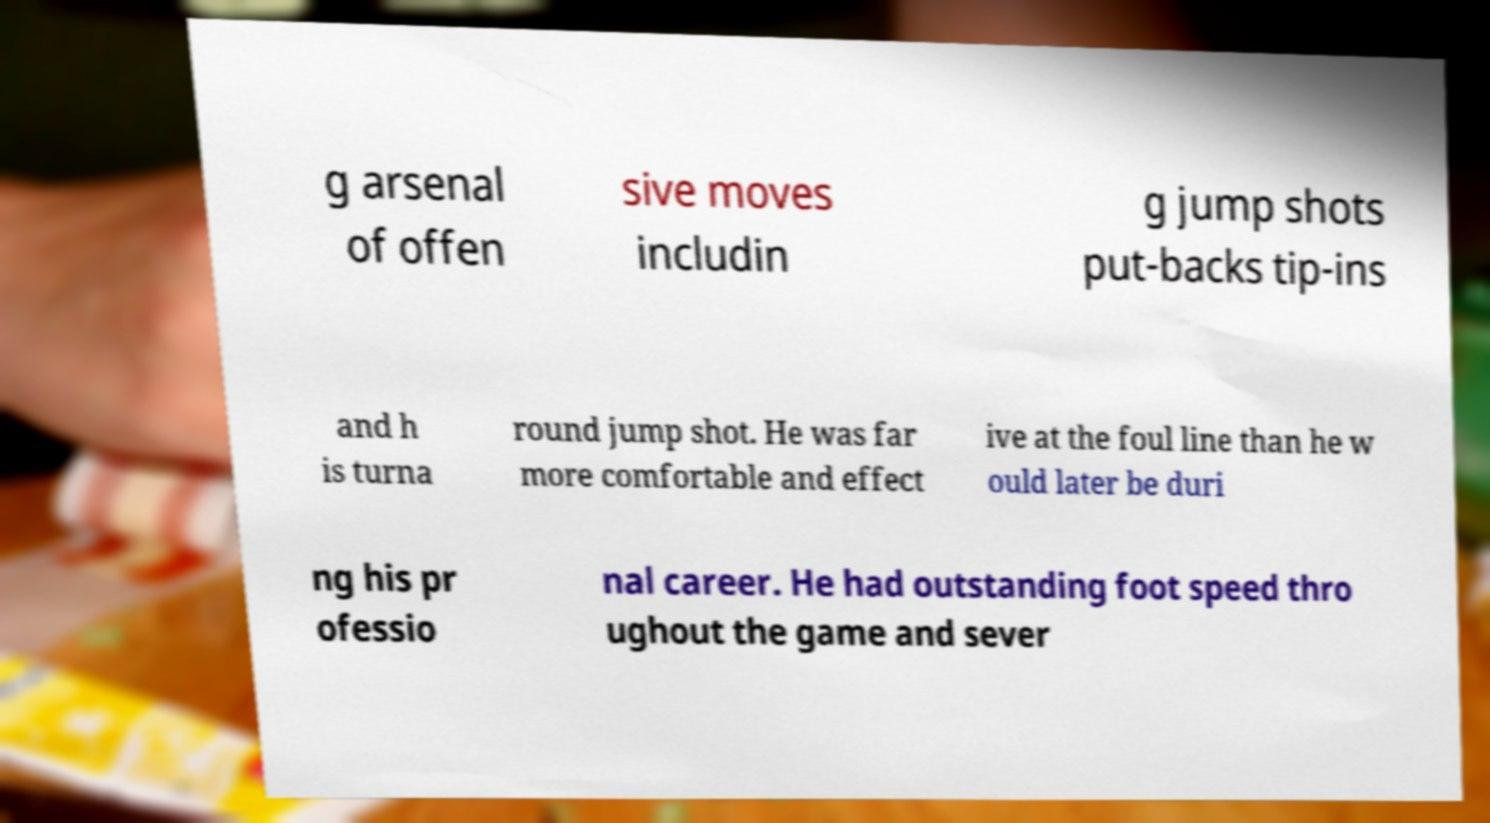Can you accurately transcribe the text from the provided image for me? g arsenal of offen sive moves includin g jump shots put-backs tip-ins and h is turna round jump shot. He was far more comfortable and effect ive at the foul line than he w ould later be duri ng his pr ofessio nal career. He had outstanding foot speed thro ughout the game and sever 